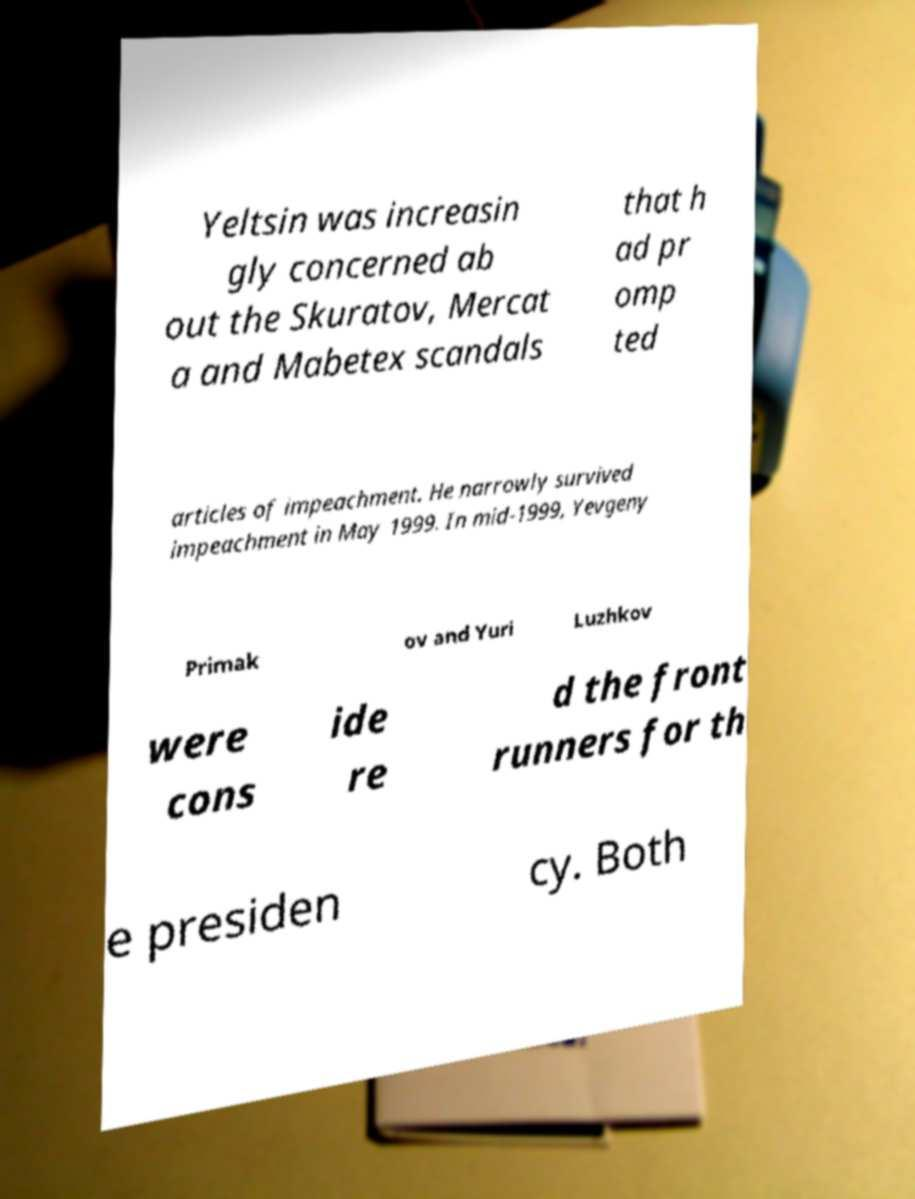For documentation purposes, I need the text within this image transcribed. Could you provide that? Yeltsin was increasin gly concerned ab out the Skuratov, Mercat a and Mabetex scandals that h ad pr omp ted articles of impeachment. He narrowly survived impeachment in May 1999. In mid-1999, Yevgeny Primak ov and Yuri Luzhkov were cons ide re d the front runners for th e presiden cy. Both 